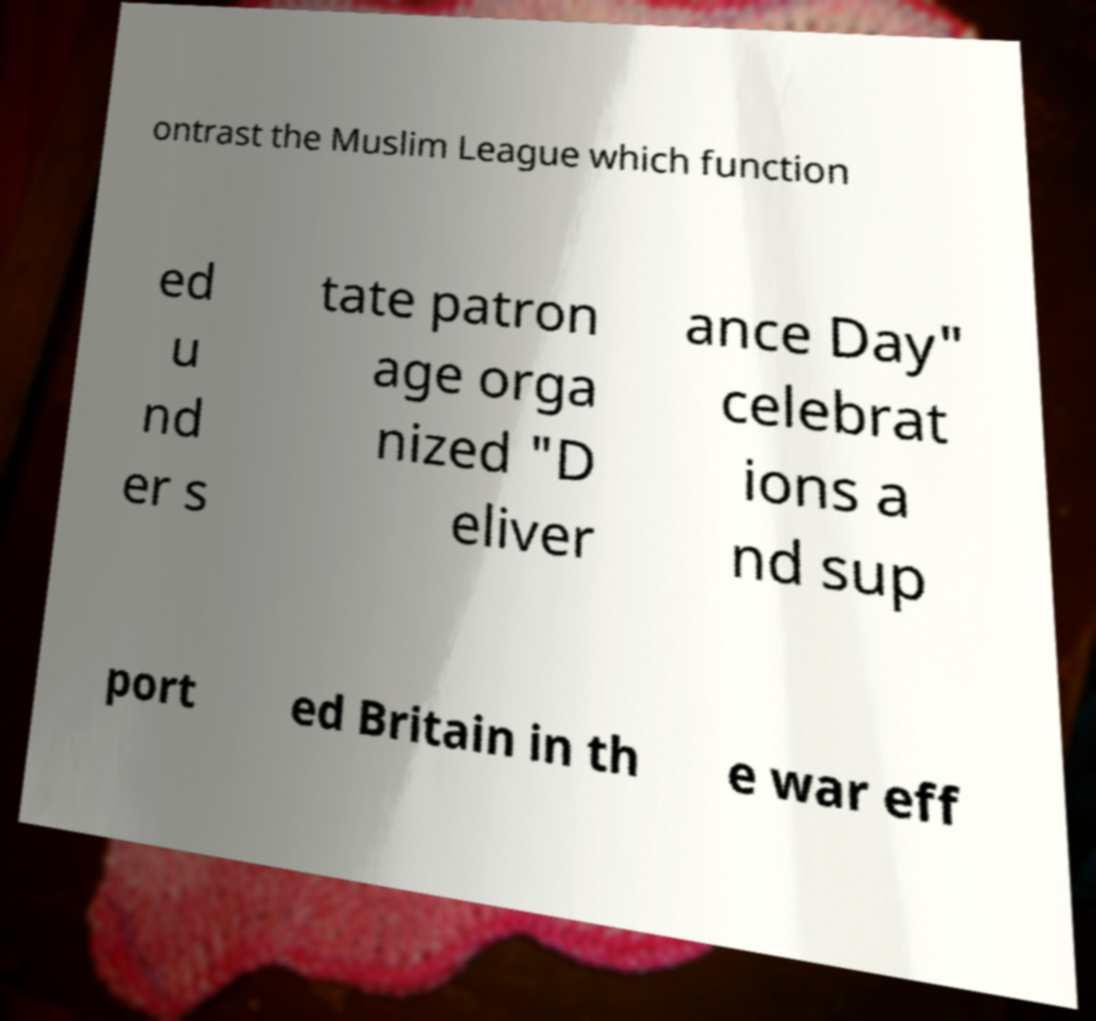What messages or text are displayed in this image? I need them in a readable, typed format. ontrast the Muslim League which function ed u nd er s tate patron age orga nized "D eliver ance Day" celebrat ions a nd sup port ed Britain in th e war eff 